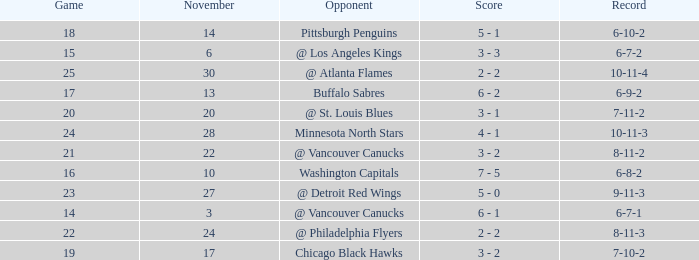What is the game when on november 27? 23.0. 